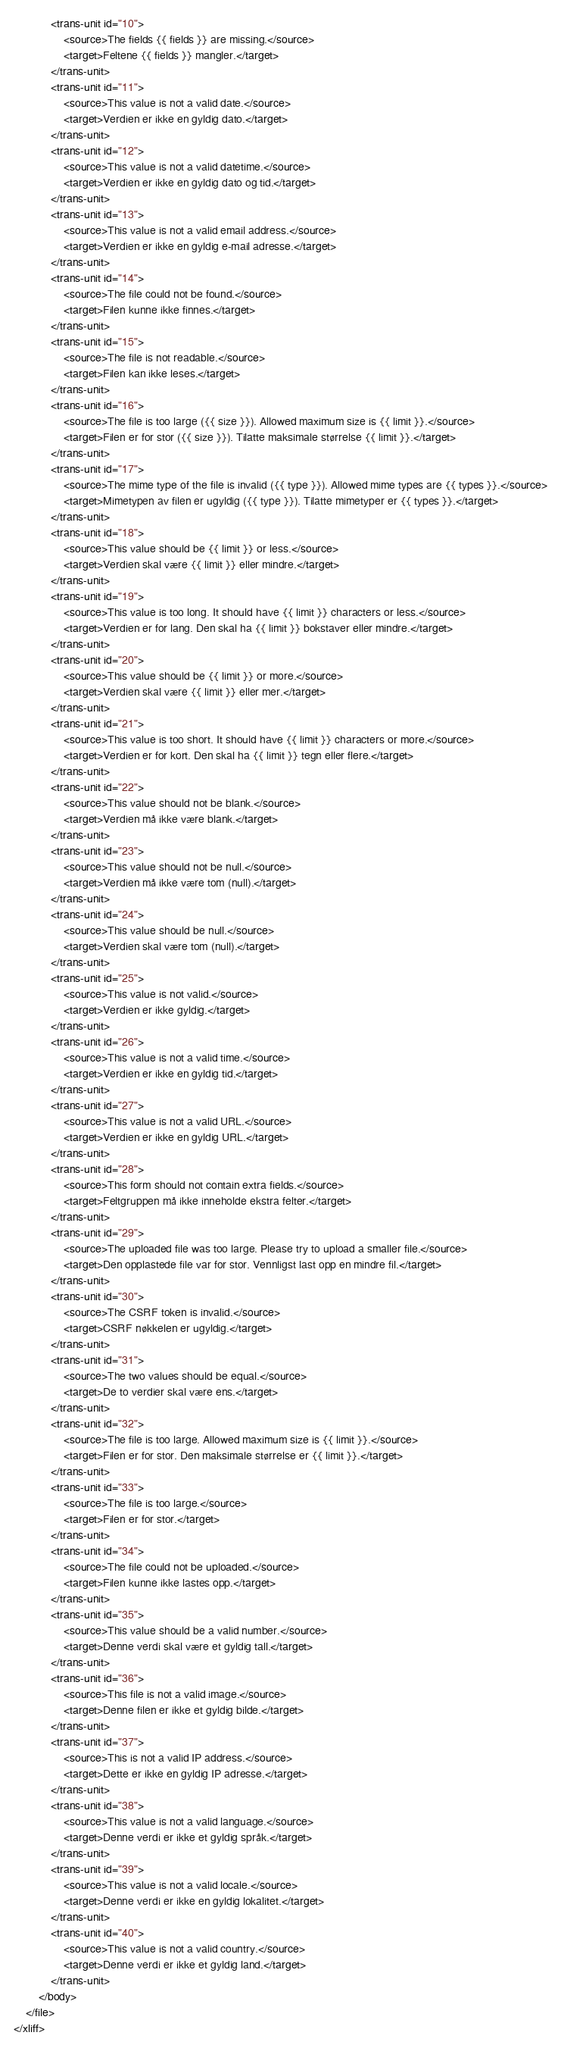Convert code to text. <code><loc_0><loc_0><loc_500><loc_500><_XML_>            <trans-unit id="10">
                <source>The fields {{ fields }} are missing.</source>
                <target>Feltene {{ fields }} mangler.</target>
            </trans-unit>
            <trans-unit id="11">
                <source>This value is not a valid date.</source>
                <target>Verdien er ikke en gyldig dato.</target>
            </trans-unit>
            <trans-unit id="12">
                <source>This value is not a valid datetime.</source>
                <target>Verdien er ikke en gyldig dato og tid.</target>
            </trans-unit>
            <trans-unit id="13">
                <source>This value is not a valid email address.</source>
                <target>Verdien er ikke en gyldig e-mail adresse.</target>
            </trans-unit>
            <trans-unit id="14">
                <source>The file could not be found.</source>
                <target>Filen kunne ikke finnes.</target>
            </trans-unit>
            <trans-unit id="15">
                <source>The file is not readable.</source>
                <target>Filen kan ikke leses.</target>
            </trans-unit>
            <trans-unit id="16">
                <source>The file is too large ({{ size }}). Allowed maximum size is {{ limit }}.</source>
                <target>Filen er for stor ({{ size }}). Tilatte maksimale størrelse {{ limit }}.</target>
            </trans-unit>
            <trans-unit id="17">
                <source>The mime type of the file is invalid ({{ type }}). Allowed mime types are {{ types }}.</source>
                <target>Mimetypen av filen er ugyldig ({{ type }}). Tilatte mimetyper er {{ types }}.</target>
            </trans-unit>
            <trans-unit id="18">
                <source>This value should be {{ limit }} or less.</source>
                <target>Verdien skal være {{ limit }} eller mindre.</target>
            </trans-unit>
            <trans-unit id="19">
                <source>This value is too long. It should have {{ limit }} characters or less.</source>
                <target>Verdien er for lang. Den skal ha {{ limit }} bokstaver eller mindre.</target>
            </trans-unit>
            <trans-unit id="20">
                <source>This value should be {{ limit }} or more.</source>
                <target>Verdien skal være {{ limit }} eller mer.</target>
            </trans-unit>
            <trans-unit id="21">
                <source>This value is too short. It should have {{ limit }} characters or more.</source>
                <target>Verdien er for kort. Den skal ha {{ limit }} tegn eller flere.</target>
            </trans-unit>
            <trans-unit id="22">
                <source>This value should not be blank.</source>
                <target>Verdien må ikke være blank.</target>
            </trans-unit>
            <trans-unit id="23">
                <source>This value should not be null.</source>
                <target>Verdien må ikke være tom (null).</target>
            </trans-unit>
            <trans-unit id="24">
                <source>This value should be null.</source>
                <target>Verdien skal være tom (null).</target>
            </trans-unit>
            <trans-unit id="25">
                <source>This value is not valid.</source>
                <target>Verdien er ikke gyldig.</target>
            </trans-unit>
            <trans-unit id="26">
                <source>This value is not a valid time.</source>
                <target>Verdien er ikke en gyldig tid.</target>
            </trans-unit>
            <trans-unit id="27">
                <source>This value is not a valid URL.</source>
                <target>Verdien er ikke en gyldig URL.</target>
            </trans-unit>
            <trans-unit id="28">
                <source>This form should not contain extra fields.</source>
                <target>Feltgruppen må ikke inneholde ekstra felter.</target>
            </trans-unit>
            <trans-unit id="29">
                <source>The uploaded file was too large. Please try to upload a smaller file.</source>
                <target>Den opplastede file var for stor. Vennligst last opp en mindre fil.</target>
            </trans-unit>
            <trans-unit id="30">
                <source>The CSRF token is invalid.</source>
                <target>CSRF nøkkelen er ugyldig.</target>
            </trans-unit>
            <trans-unit id="31">
                <source>The two values should be equal.</source>
                <target>De to verdier skal være ens.</target>
            </trans-unit>
            <trans-unit id="32">
                <source>The file is too large. Allowed maximum size is {{ limit }}.</source>
                <target>Filen er for stor. Den maksimale størrelse er {{ limit }}.</target>
            </trans-unit>
            <trans-unit id="33">
                <source>The file is too large.</source>
                <target>Filen er for stor.</target>
            </trans-unit>
            <trans-unit id="34">
                <source>The file could not be uploaded.</source>
                <target>Filen kunne ikke lastes opp.</target>
            </trans-unit>
            <trans-unit id="35">
                <source>This value should be a valid number.</source>
                <target>Denne verdi skal være et gyldig tall.</target>
            </trans-unit>
            <trans-unit id="36">
                <source>This file is not a valid image.</source>
                <target>Denne filen er ikke et gyldig bilde.</target>
            </trans-unit>
            <trans-unit id="37">
                <source>This is not a valid IP address.</source>
                <target>Dette er ikke en gyldig IP adresse.</target>
            </trans-unit>
            <trans-unit id="38">
                <source>This value is not a valid language.</source>
                <target>Denne verdi er ikke et gyldig språk.</target>
            </trans-unit>
            <trans-unit id="39">
                <source>This value is not a valid locale.</source>
                <target>Denne verdi er ikke en gyldig lokalitet.</target>
            </trans-unit>
            <trans-unit id="40">
                <source>This value is not a valid country.</source>
                <target>Denne verdi er ikke et gyldig land.</target>
            </trans-unit>
        </body>
    </file>
</xliff>
</code> 